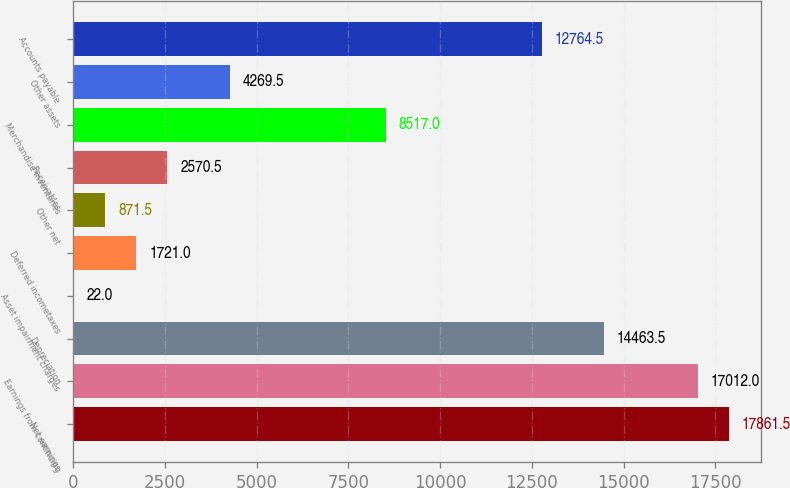Convert chart to OTSL. <chart><loc_0><loc_0><loc_500><loc_500><bar_chart><fcel>Net earnings<fcel>Earnings from continuing<fcel>Depreciation<fcel>Asset impairment charges<fcel>Deferred incometaxes<fcel>Other net<fcel>Receivables<fcel>Merchandise inventories<fcel>Other assets<fcel>Accounts payable<nl><fcel>17861.5<fcel>17012<fcel>14463.5<fcel>22<fcel>1721<fcel>871.5<fcel>2570.5<fcel>8517<fcel>4269.5<fcel>12764.5<nl></chart> 